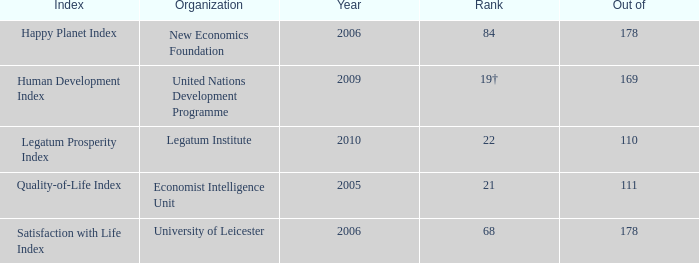What year is the happy planet index? 2006.0. 